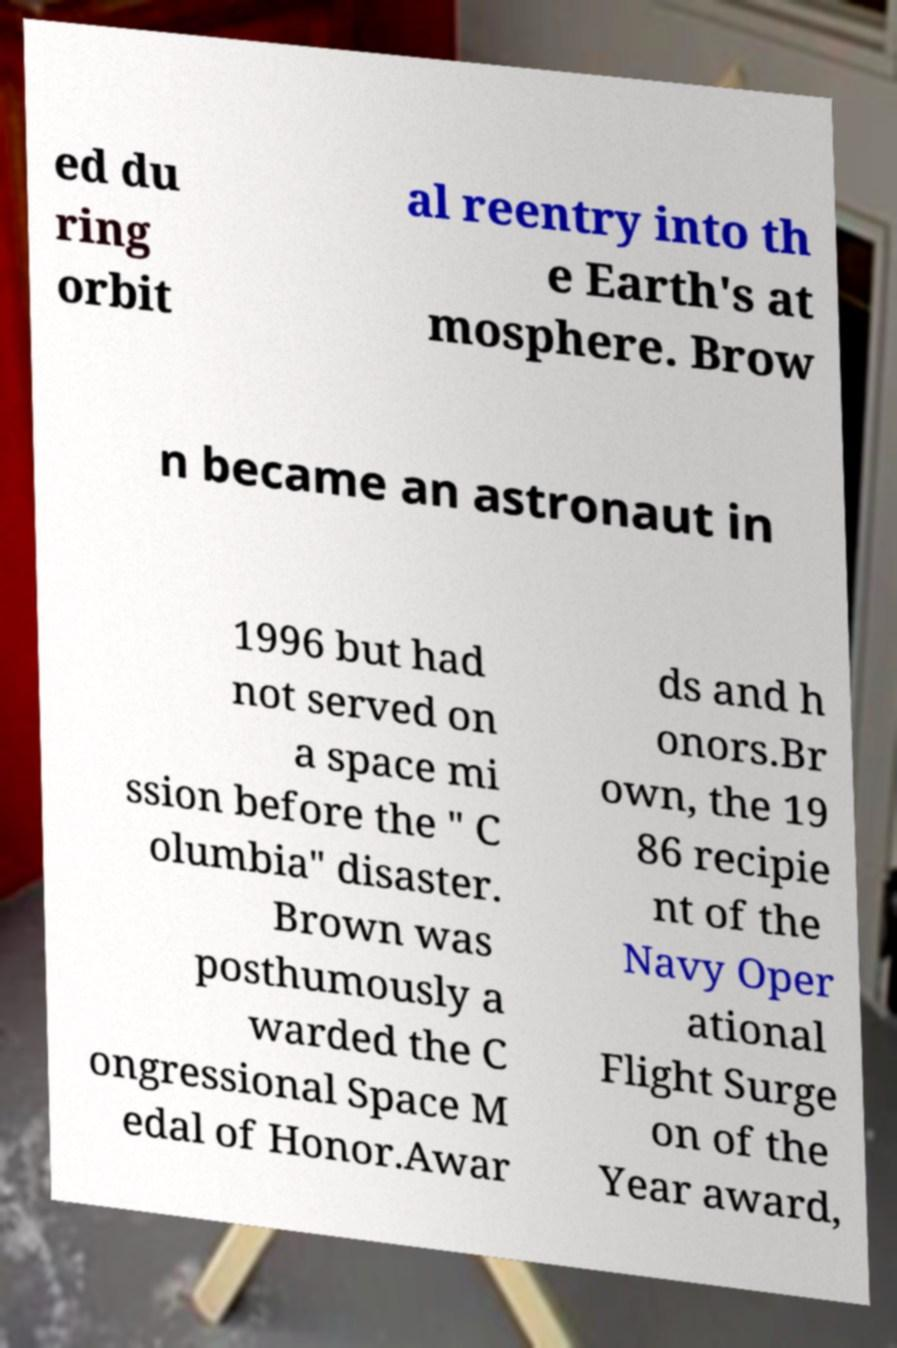I need the written content from this picture converted into text. Can you do that? ed du ring orbit al reentry into th e Earth's at mosphere. Brow n became an astronaut in 1996 but had not served on a space mi ssion before the " C olumbia" disaster. Brown was posthumously a warded the C ongressional Space M edal of Honor.Awar ds and h onors.Br own, the 19 86 recipie nt of the Navy Oper ational Flight Surge on of the Year award, 